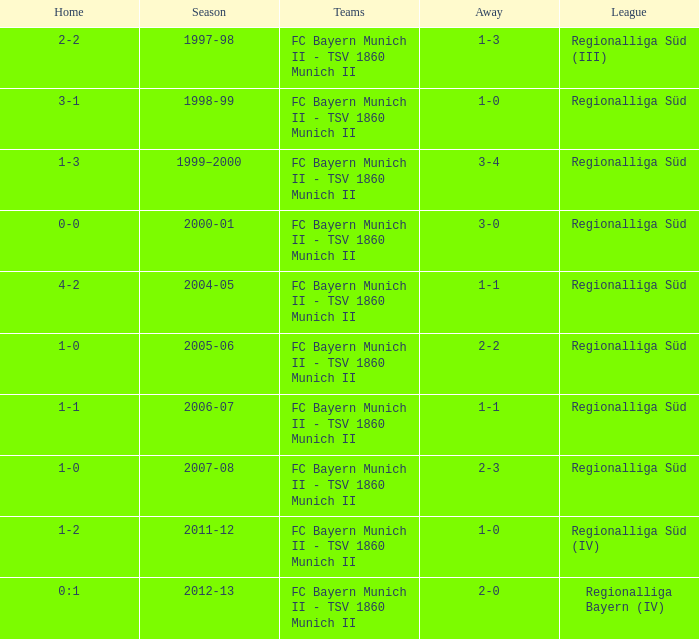What is the league with a 0:1 home? Regionalliga Bayern (IV). 